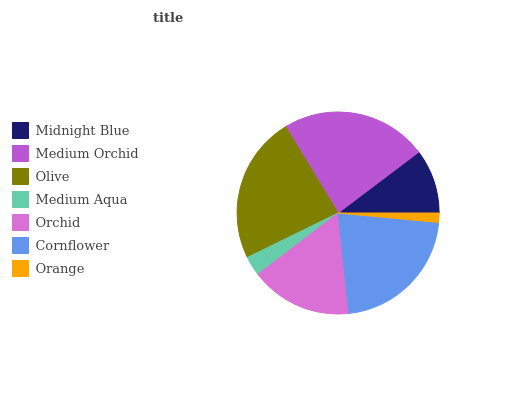Is Orange the minimum?
Answer yes or no. Yes. Is Olive the maximum?
Answer yes or no. Yes. Is Medium Orchid the minimum?
Answer yes or no. No. Is Medium Orchid the maximum?
Answer yes or no. No. Is Medium Orchid greater than Midnight Blue?
Answer yes or no. Yes. Is Midnight Blue less than Medium Orchid?
Answer yes or no. Yes. Is Midnight Blue greater than Medium Orchid?
Answer yes or no. No. Is Medium Orchid less than Midnight Blue?
Answer yes or no. No. Is Orchid the high median?
Answer yes or no. Yes. Is Orchid the low median?
Answer yes or no. Yes. Is Cornflower the high median?
Answer yes or no. No. Is Midnight Blue the low median?
Answer yes or no. No. 